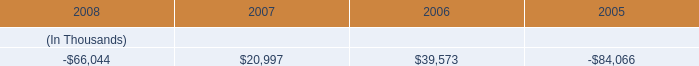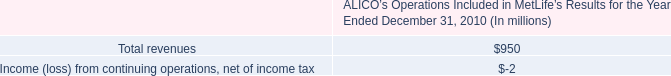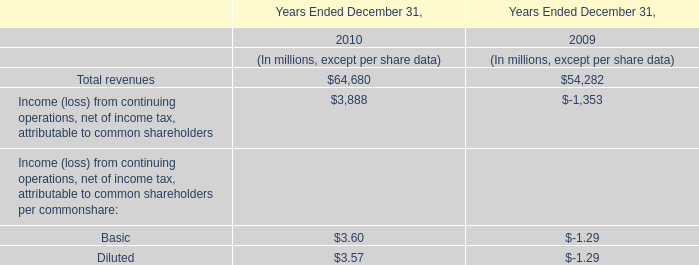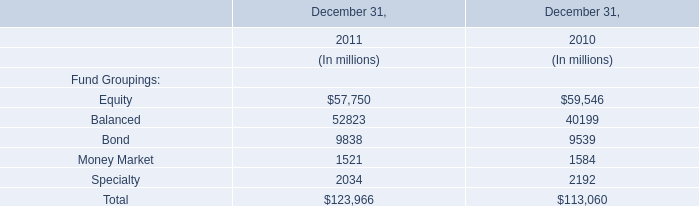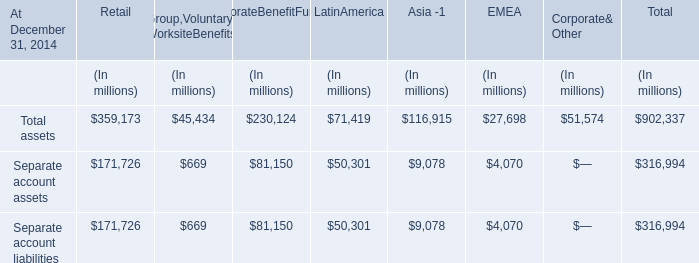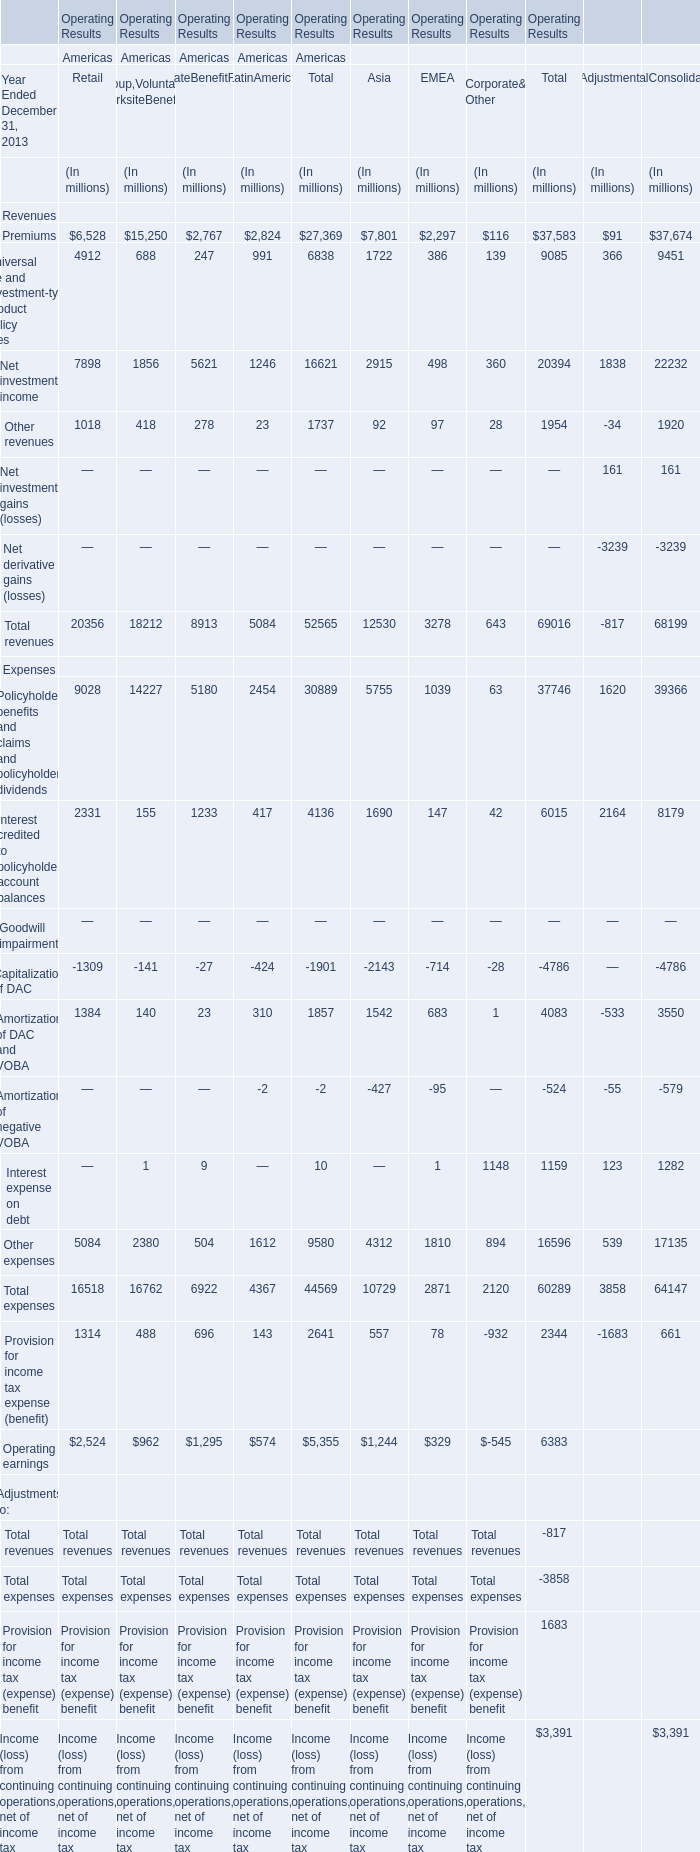What was the sum of Revenues of Premiums without those Premiums smaller than 3000 million dollars in Americas? (in million) 
Computations: (6528 + 15250)
Answer: 21778.0. 